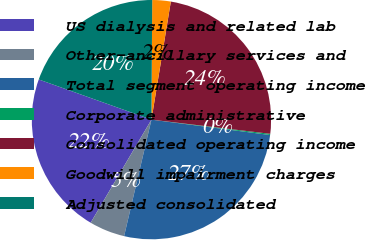Convert chart to OTSL. <chart><loc_0><loc_0><loc_500><loc_500><pie_chart><fcel>US dialysis and related lab<fcel>Other-ancillary services and<fcel>Total segment operating income<fcel>Corporate administrative<fcel>Consolidated operating income<fcel>Goodwill impairment charges<fcel>Adjusted consolidated<nl><fcel>21.97%<fcel>4.81%<fcel>26.62%<fcel>0.16%<fcel>24.3%<fcel>2.49%<fcel>19.65%<nl></chart> 